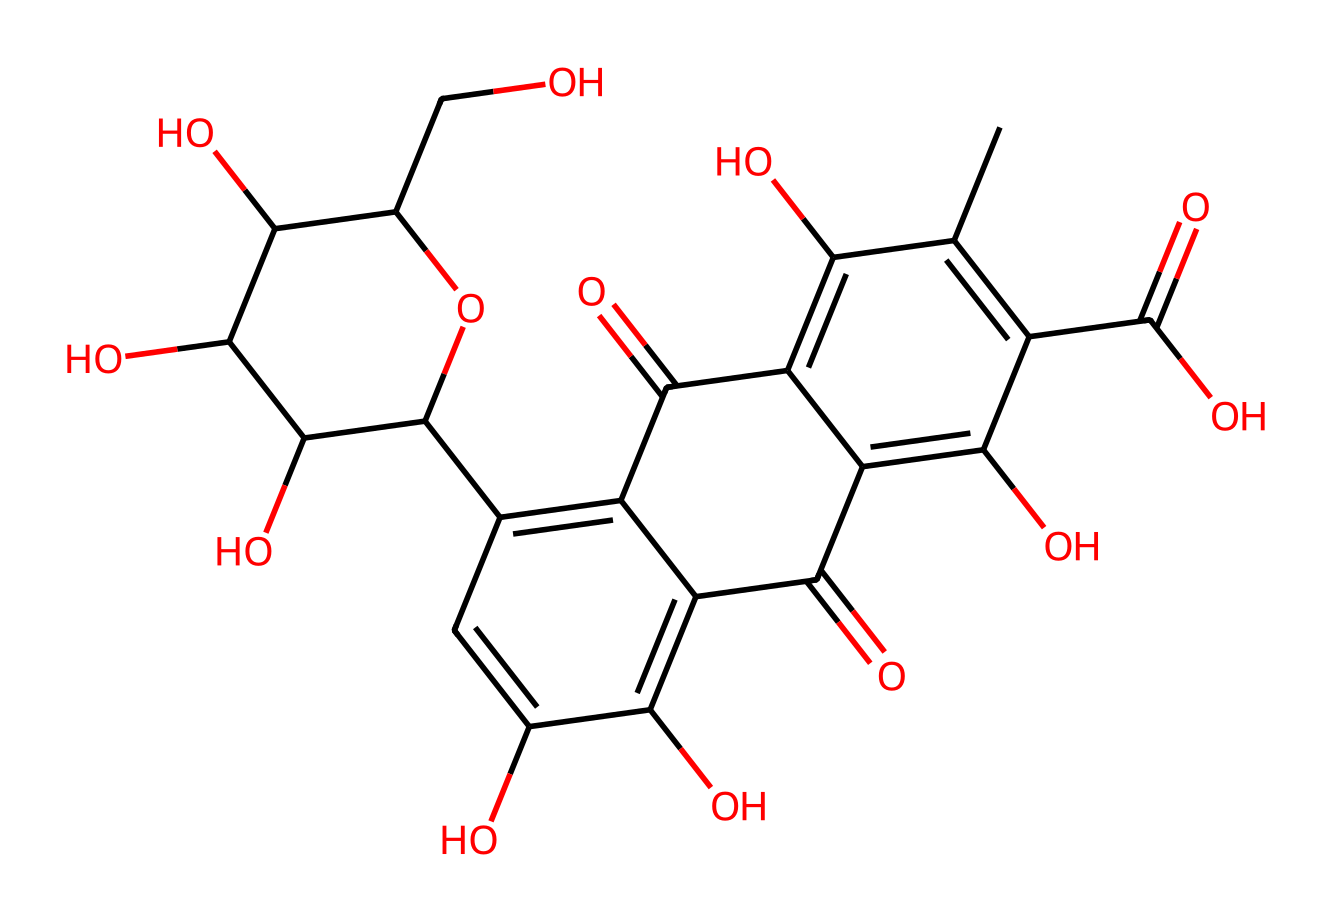What is the molecular formula of carminic acid? To determine the molecular formula, we need to count the number of each type of atom in the SMILES representation. The SMILES indicates the presence of carbon (C), hydrogen (H), and oxygen (O). By analyzing the structure, we find there are 22 carbon atoms, 24 hydrogen atoms, and 10 oxygen atoms yielding the formula C22H24O10.
Answer: C22H24O10 How many hydroxyl groups (–OH) are present in carminic acid? By examining the structure, we look for –OH groups which are indicative of alcohols and phenolic compounds. Counting the –OH groups as indicated by the "O" atoms bonded to hydrogen, we find there are 5 hydroxyl groups in the molecule.
Answer: 5 What is the primary functional group of carminic acid? In the structure, we look for recognizable functional groups. The presence of multiple hydroxyl (–OH) groups suggests that the primary functional group is phenolic, combined with the presence of carboxylic acid (–COOH) groups. However, the dominant characterization relates to its properties as an anthraquinone dye where the structure primarily indicates hydroxyl and carbonyl functionalities.
Answer: phenolic What type of dye is carminic acid classified as? Examining the molecular structure leads us to classify it based on the aromatic and colored properties of the compound. Carminic acid is classified as a natural dye, specifically an anthraquinone dye, because it is derived from a natural source (insects) and its structure contains an anthraquinone backbone responsible for its vibrant red color.
Answer: natural dye How does the chemical structure of carminic acid contribute to its color? The molecular structure contains extensive conjugation and alternating double bonds, primarily due to the presence of the aromatic rings. This conjugation allows for the absorption of visible light in a particular range, which is typically associated with red color. The electron-rich environment created by the functional groups enhances this ability, leading to the intense coloration observed.
Answer: conjugation What role do the carboxylic groups play in carminic acid's solubility? The carboxylic groups (-COOH) present in the structure are polar and capable of forming hydrogen bonds with water, thereby increasing the overall polarity of the molecule and enhancing its solubility in aqueous environments. This is crucial for its application as a dye since it helps in dispersing the dye effectively in solution.
Answer: solubility 